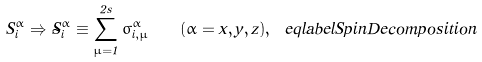<formula> <loc_0><loc_0><loc_500><loc_500>S ^ { \alpha } _ { i } \Rightarrow \tilde { S } ^ { \alpha } _ { i } \equiv \sum _ { \mu = 1 } ^ { 2 s } \sigma ^ { \alpha } _ { i , \mu } \quad ( \alpha = x , y , z ) , \ e q l a b e l { S p i n D e c o m p o s i t i o n }</formula> 